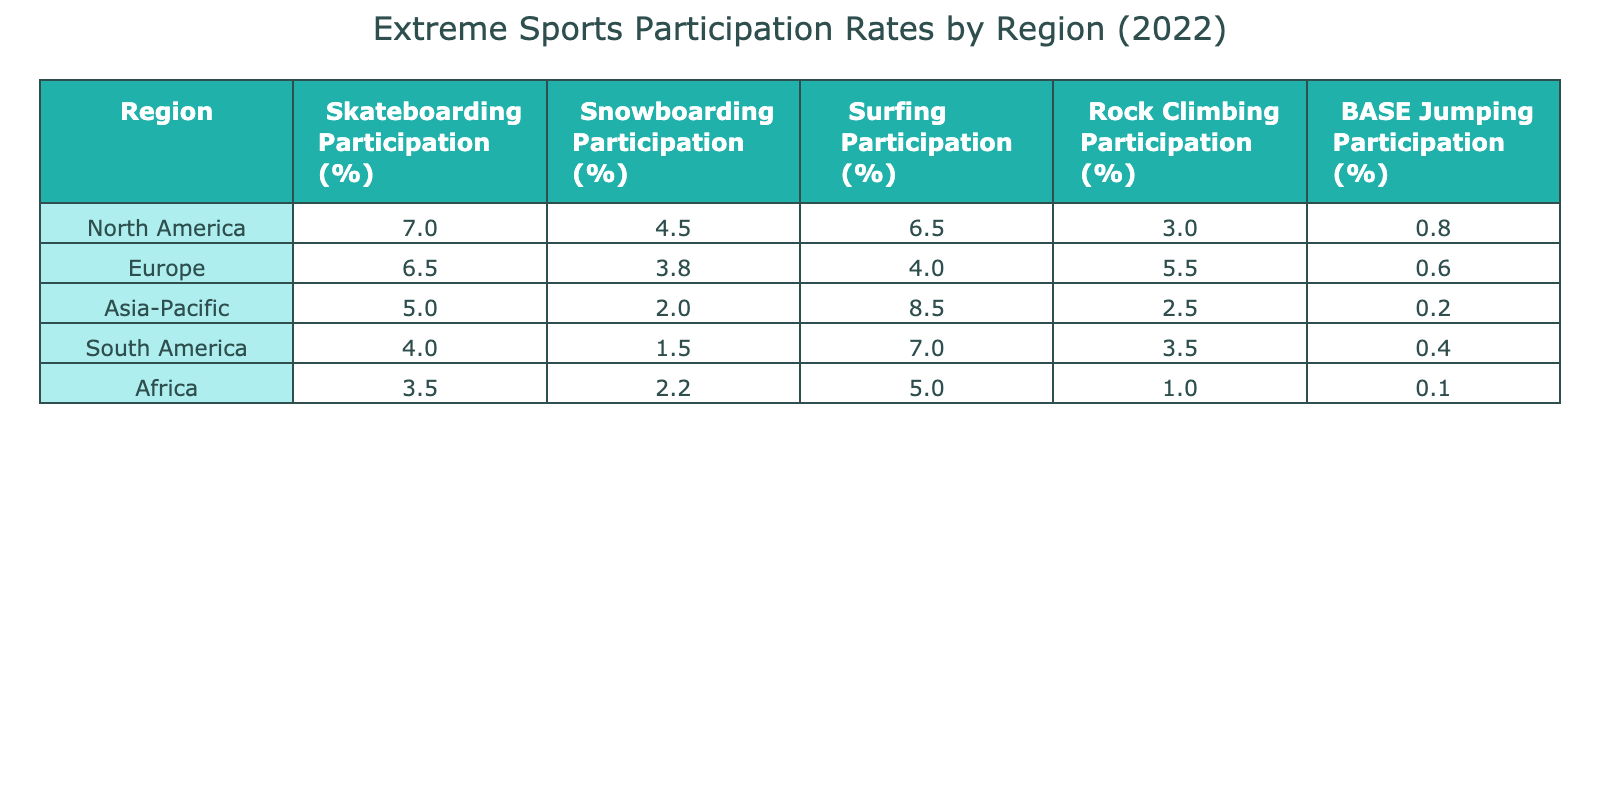What is the skateboarding participation percentage in North America? According to the table, North America has a skateboarding participation rate of 7.0%.
Answer: 7.0% Which region has the highest snowboarding participation rate? The table shows that North America has the highest snowboarding participation rate at 4.5%.
Answer: North America What is the average surfing participation percentage across all regions? To find the average, sum up all surfing participation rates: (6.5 + 4.0 + 8.5 + 7.0 + 5.0) = 31.0. Divide by the number of regions (5): 31.0 / 5 = 6.2%.
Answer: 6.2% Is there any region where BASE jumping participation is higher than 1%? By looking at the BASE jumping rates, the only region with participation higher than 1% is North America at 0.8%, and the other regions have numbers lower than that, making it a false statement.
Answer: No What is the difference in rock climbing participation rates between Europe and Asia-Pacific? The rock climbing participation in Europe is 5.5% and in Asia-Pacific is 2.5%. Subtract the lower from the higher: 5.5 - 2.5 = 3.0%.
Answer: 3.0% Which region has the lowest participation in BASE jumping? Observing the BASE jumping participation rates, Africa shows the lowest rate at 0.1%.
Answer: Africa What percentage of people participate in skateboarding in South America? The table indicates that skateboarding participation in South America is 4.0%.
Answer: 4.0% Is surfing participation higher in Asia-Pacific than in Europe? The surfing participation rates show Asia-Pacific at 8.5% and Europe at 4.0%, which confirms that Asia-Pacific has a higher participation in surfing.
Answer: Yes 